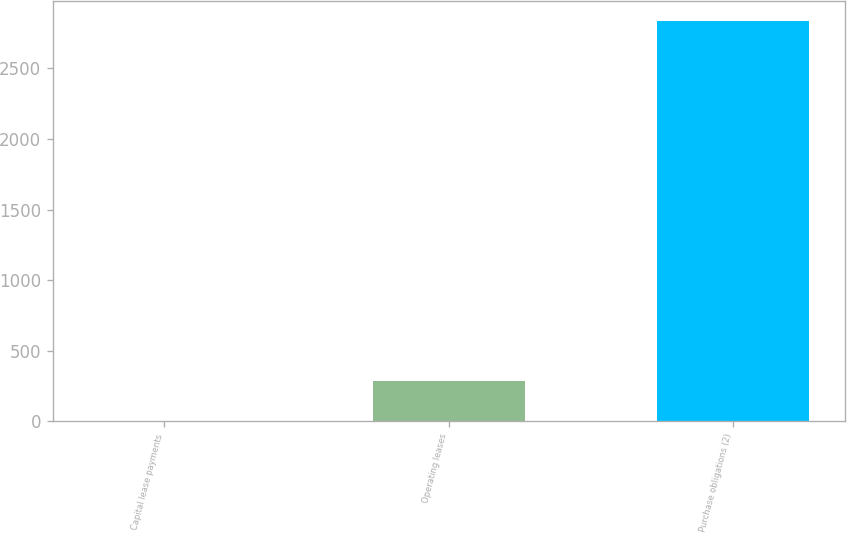Convert chart. <chart><loc_0><loc_0><loc_500><loc_500><bar_chart><fcel>Capital lease payments<fcel>Operating leases<fcel>Purchase obligations (2)<nl><fcel>2<fcel>285.8<fcel>2840<nl></chart> 